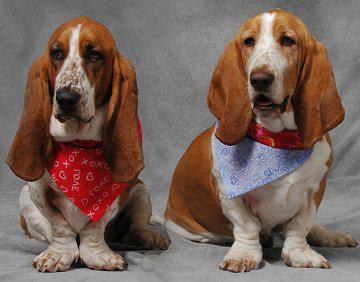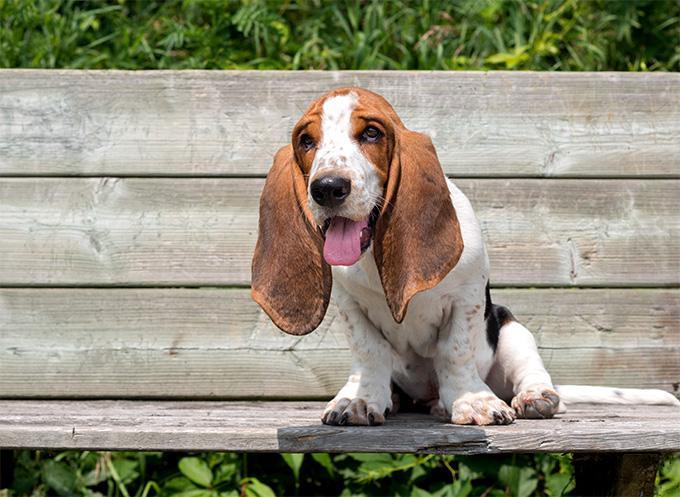The first image is the image on the left, the second image is the image on the right. Assess this claim about the two images: "One of the dog has its chin on a surface.". Correct or not? Answer yes or no. No. 